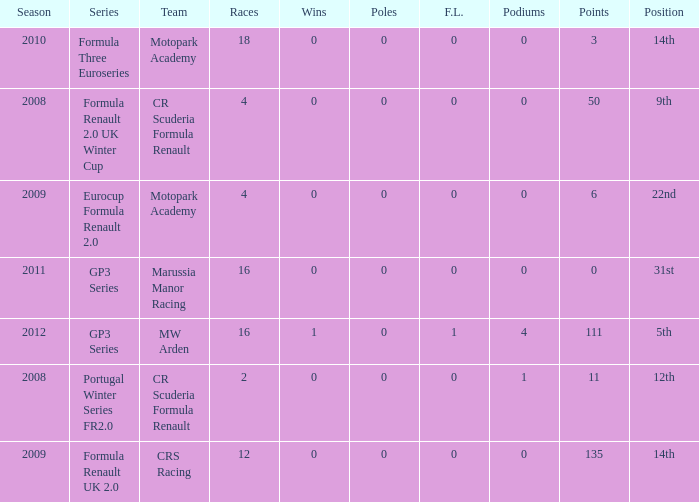What are the most poles listed? 0.0. 